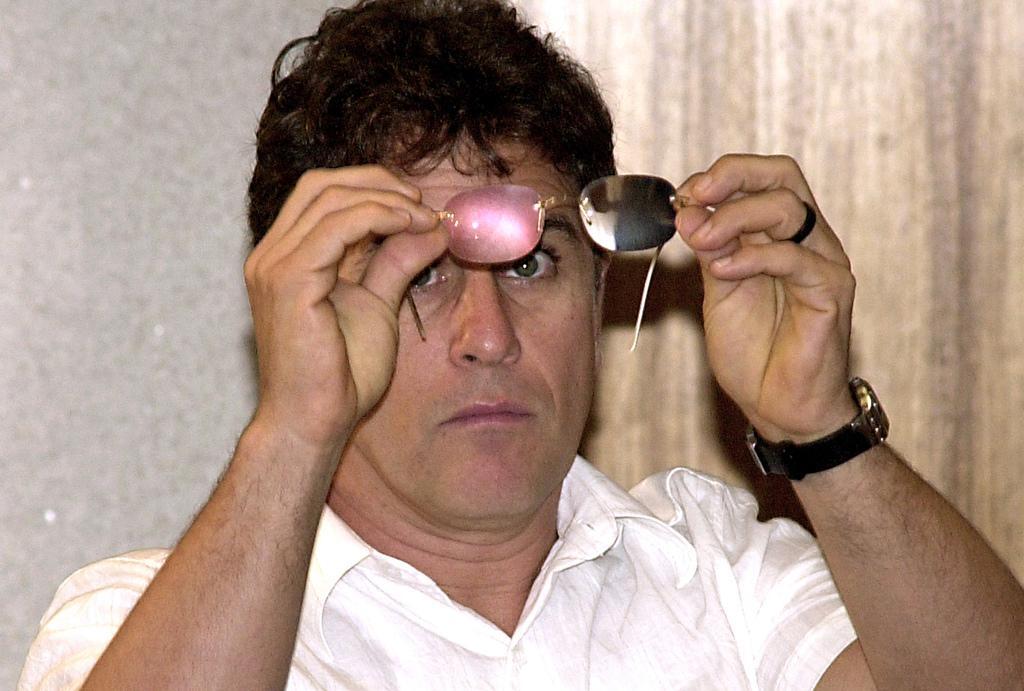In one or two sentences, can you explain what this image depicts? In this image I can see a person holding spectacles and there is a wall and curtains at the back. 